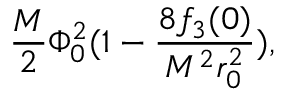Convert formula to latex. <formula><loc_0><loc_0><loc_500><loc_500>\frac { M } { 2 } \Phi _ { 0 } ^ { 2 } ( 1 - \frac { 8 f _ { 3 } ( 0 ) } { M ^ { 2 } r _ { 0 } ^ { 2 } } ) ,</formula> 